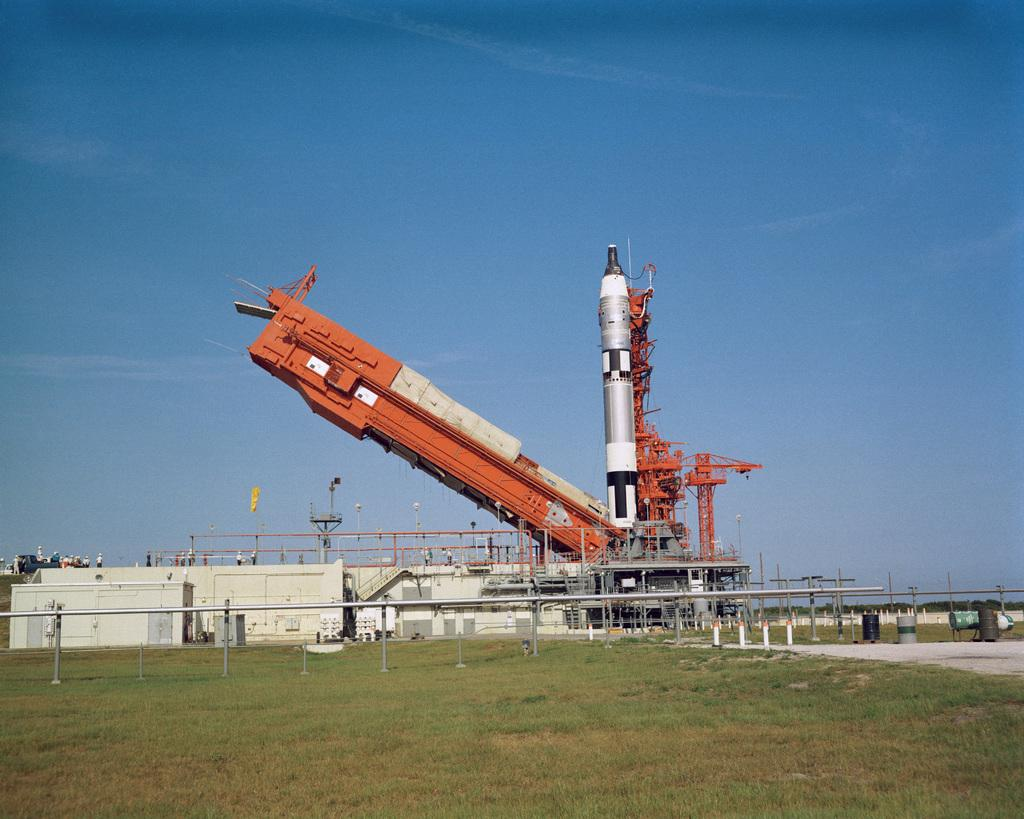What type of structure can be seen in the image? There is a building in the image. What is the most prominent feature on the ground in the image? There is a rocket on a launching pad in the image. What type of terrain is visible in the image? Water and grass are present on the ground in the image. What is the color of the sky in the image? The sky is blue in the image. Is there any symbol or emblem present in the image? Yes, there is a flag in the image. Can you see any wounds on the rocket in the image? There are no wounds visible on the rocket in the image, as it is a man-made object and not a living being. Are there any shoes visible in the image? There are no shoes present in the image. 